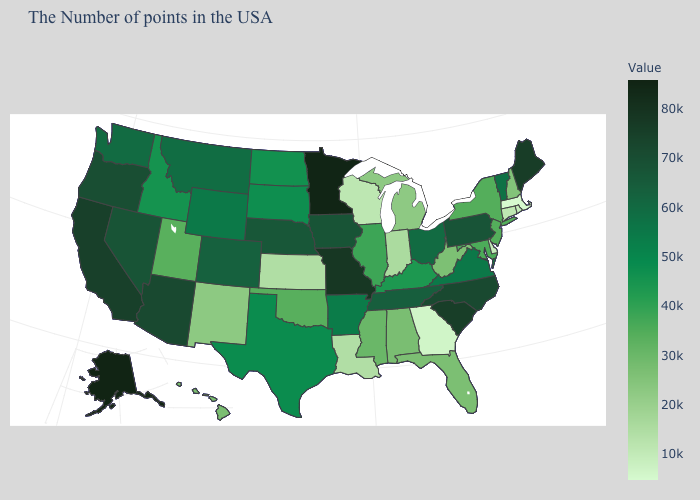Which states have the lowest value in the West?
Short answer required. New Mexico. Which states have the lowest value in the USA?
Give a very brief answer. Massachusetts. Which states have the lowest value in the Northeast?
Short answer required. Massachusetts. Does Minnesota have the highest value in the MidWest?
Quick response, please. Yes. Is the legend a continuous bar?
Give a very brief answer. Yes. 